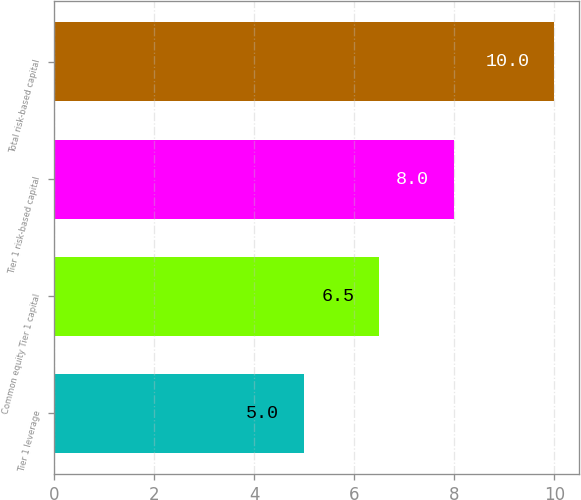Convert chart to OTSL. <chart><loc_0><loc_0><loc_500><loc_500><bar_chart><fcel>Tier 1 leverage<fcel>Common equity Tier 1 capital<fcel>Tier 1 risk-based capital<fcel>Total risk-based capital<nl><fcel>5<fcel>6.5<fcel>8<fcel>10<nl></chart> 